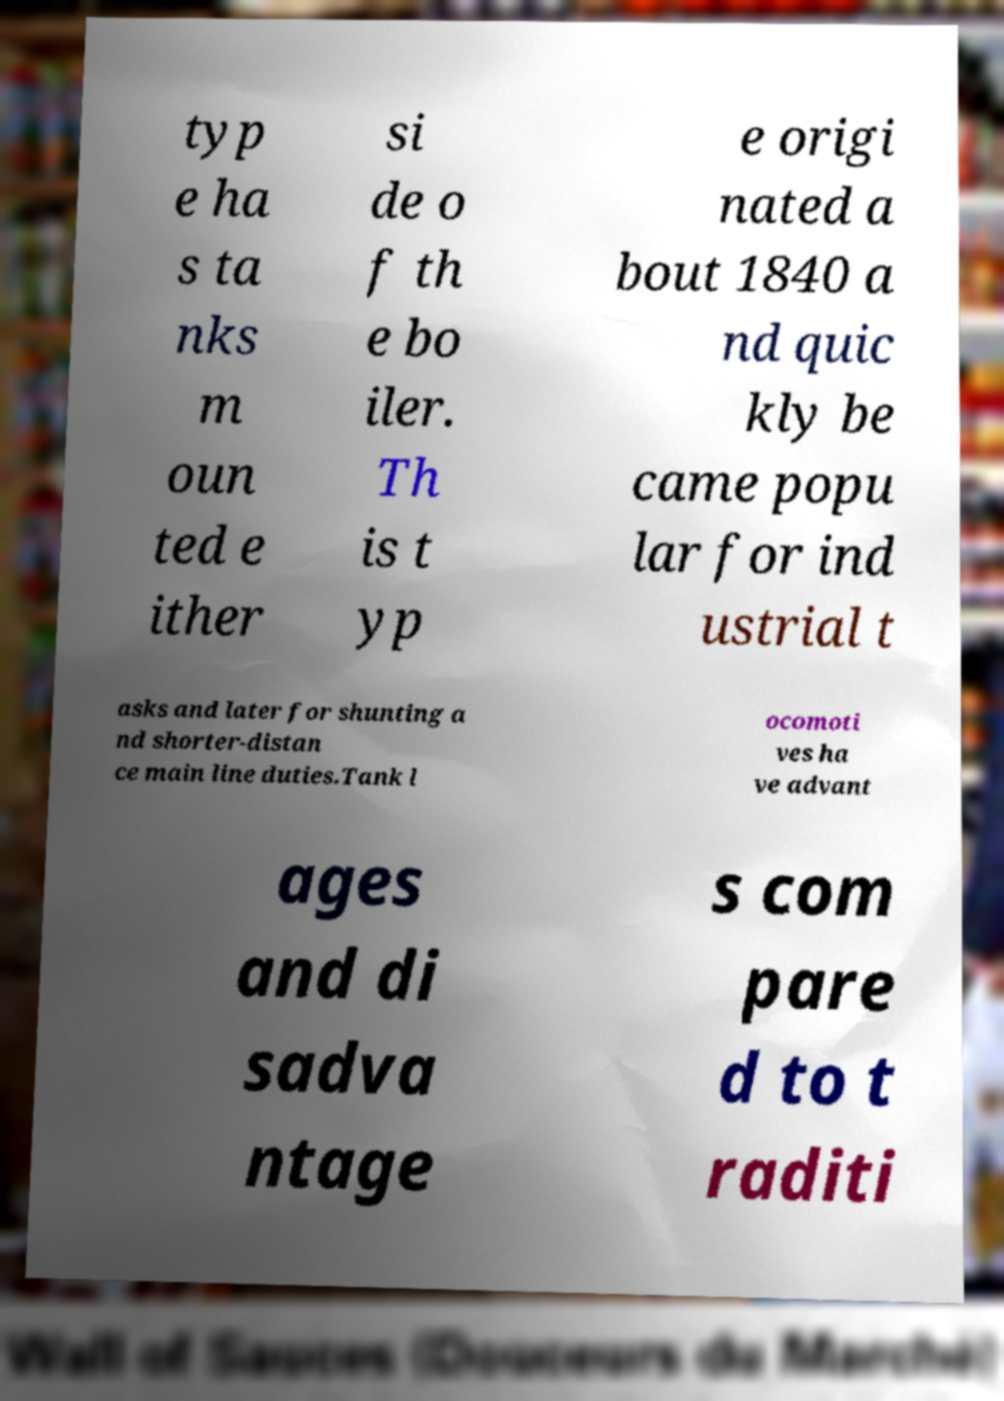Can you accurately transcribe the text from the provided image for me? typ e ha s ta nks m oun ted e ither si de o f th e bo iler. Th is t yp e origi nated a bout 1840 a nd quic kly be came popu lar for ind ustrial t asks and later for shunting a nd shorter-distan ce main line duties.Tank l ocomoti ves ha ve advant ages and di sadva ntage s com pare d to t raditi 